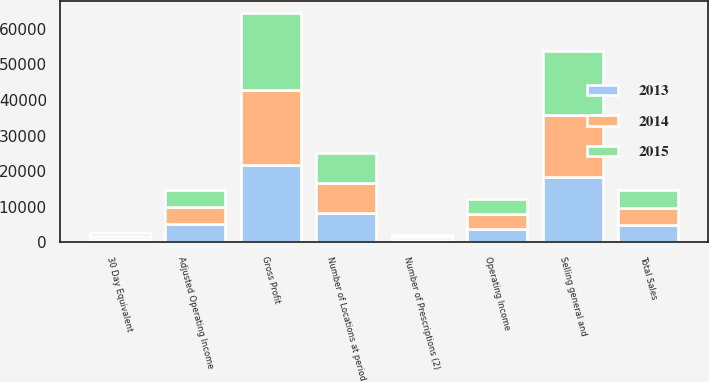Convert chart. <chart><loc_0><loc_0><loc_500><loc_500><stacked_bar_chart><ecel><fcel>Total Sales<fcel>Gross Profit<fcel>Selling general and<fcel>Operating Income<fcel>Adjusted Operating Income<fcel>Number of Prescriptions (2)<fcel>30 Day Equivalent<fcel>Number of Locations at period<nl><fcel>2013<fcel>4866<fcel>21822<fcel>18247<fcel>3890<fcel>5098<fcel>723<fcel>894<fcel>8182<nl><fcel>2015<fcel>4866<fcel>21569<fcel>17992<fcel>4194<fcel>4866<fcel>699<fcel>856<fcel>8309<nl><fcel>2014<fcel>4866<fcel>21119<fcel>17543<fcel>4092<fcel>4828<fcel>683<fcel>821<fcel>8582<nl></chart> 